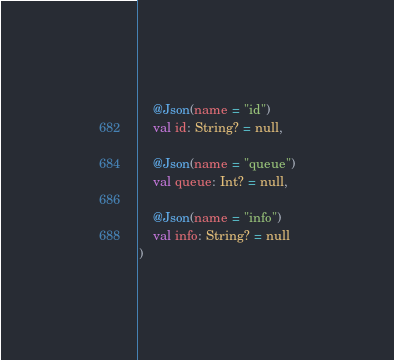<code> <loc_0><loc_0><loc_500><loc_500><_Kotlin_>
    @Json(name = "id")
    val id: String? = null,

    @Json(name = "queue")
    val queue: Int? = null,

    @Json(name = "info")
    val info: String? = null
)
</code> 